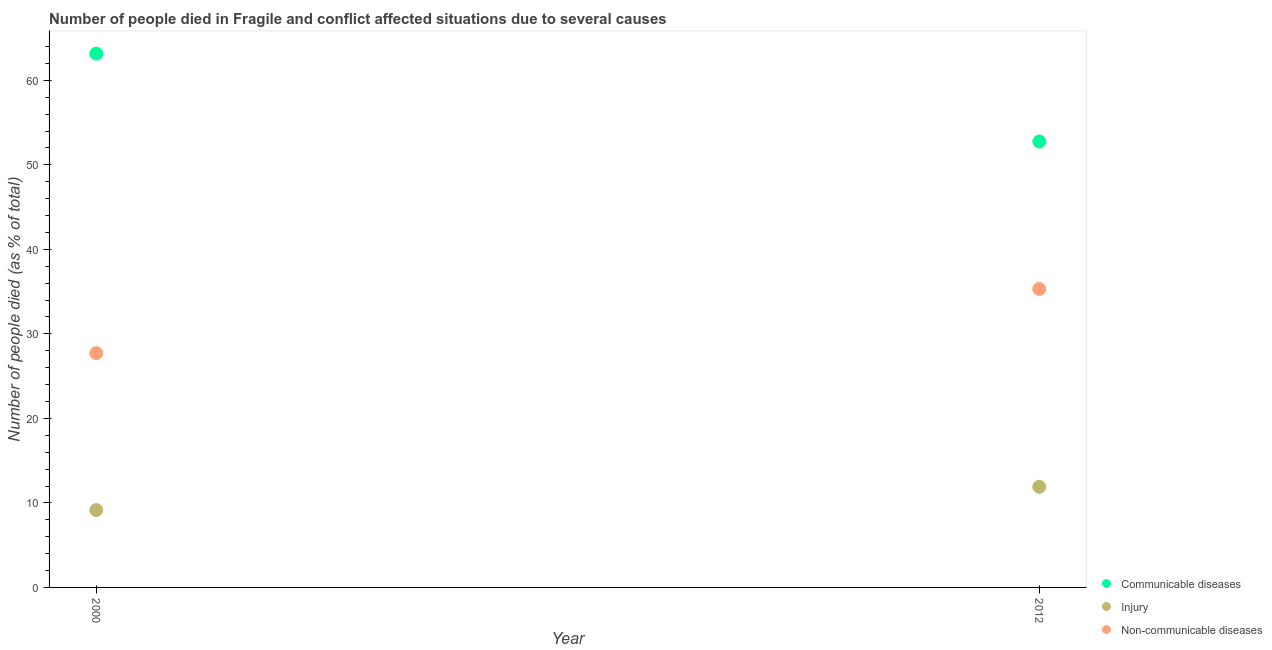How many different coloured dotlines are there?
Ensure brevity in your answer.  3. What is the number of people who dies of non-communicable diseases in 2012?
Make the answer very short. 35.31. Across all years, what is the maximum number of people who dies of non-communicable diseases?
Provide a succinct answer. 35.31. Across all years, what is the minimum number of people who died of injury?
Give a very brief answer. 9.15. In which year was the number of people who dies of non-communicable diseases maximum?
Keep it short and to the point. 2012. In which year was the number of people who dies of non-communicable diseases minimum?
Provide a succinct answer. 2000. What is the total number of people who died of communicable diseases in the graph?
Offer a very short reply. 115.91. What is the difference between the number of people who dies of non-communicable diseases in 2000 and that in 2012?
Provide a short and direct response. -7.59. What is the difference between the number of people who died of communicable diseases in 2012 and the number of people who dies of non-communicable diseases in 2000?
Keep it short and to the point. 25.04. What is the average number of people who dies of non-communicable diseases per year?
Give a very brief answer. 31.52. In the year 2012, what is the difference between the number of people who dies of non-communicable diseases and number of people who died of injury?
Provide a short and direct response. 23.41. What is the ratio of the number of people who dies of non-communicable diseases in 2000 to that in 2012?
Ensure brevity in your answer.  0.78. Is it the case that in every year, the sum of the number of people who died of communicable diseases and number of people who died of injury is greater than the number of people who dies of non-communicable diseases?
Offer a very short reply. Yes. How many dotlines are there?
Offer a terse response. 3. How many years are there in the graph?
Give a very brief answer. 2. Are the values on the major ticks of Y-axis written in scientific E-notation?
Provide a short and direct response. No. Does the graph contain any zero values?
Provide a succinct answer. No. How many legend labels are there?
Ensure brevity in your answer.  3. What is the title of the graph?
Provide a succinct answer. Number of people died in Fragile and conflict affected situations due to several causes. What is the label or title of the X-axis?
Your answer should be very brief. Year. What is the label or title of the Y-axis?
Your response must be concise. Number of people died (as % of total). What is the Number of people died (as % of total) of Communicable diseases in 2000?
Provide a succinct answer. 63.15. What is the Number of people died (as % of total) in Injury in 2000?
Give a very brief answer. 9.15. What is the Number of people died (as % of total) of Non-communicable diseases in 2000?
Your response must be concise. 27.72. What is the Number of people died (as % of total) in Communicable diseases in 2012?
Provide a succinct answer. 52.76. What is the Number of people died (as % of total) of Injury in 2012?
Provide a short and direct response. 11.91. What is the Number of people died (as % of total) of Non-communicable diseases in 2012?
Keep it short and to the point. 35.31. Across all years, what is the maximum Number of people died (as % of total) in Communicable diseases?
Offer a very short reply. 63.15. Across all years, what is the maximum Number of people died (as % of total) in Injury?
Give a very brief answer. 11.91. Across all years, what is the maximum Number of people died (as % of total) in Non-communicable diseases?
Offer a terse response. 35.31. Across all years, what is the minimum Number of people died (as % of total) in Communicable diseases?
Ensure brevity in your answer.  52.76. Across all years, what is the minimum Number of people died (as % of total) of Injury?
Ensure brevity in your answer.  9.15. Across all years, what is the minimum Number of people died (as % of total) of Non-communicable diseases?
Provide a succinct answer. 27.72. What is the total Number of people died (as % of total) of Communicable diseases in the graph?
Keep it short and to the point. 115.91. What is the total Number of people died (as % of total) in Injury in the graph?
Offer a terse response. 21.06. What is the total Number of people died (as % of total) of Non-communicable diseases in the graph?
Your answer should be compact. 63.03. What is the difference between the Number of people died (as % of total) in Communicable diseases in 2000 and that in 2012?
Offer a terse response. 10.39. What is the difference between the Number of people died (as % of total) in Injury in 2000 and that in 2012?
Your answer should be very brief. -2.75. What is the difference between the Number of people died (as % of total) of Non-communicable diseases in 2000 and that in 2012?
Provide a short and direct response. -7.59. What is the difference between the Number of people died (as % of total) of Communicable diseases in 2000 and the Number of people died (as % of total) of Injury in 2012?
Ensure brevity in your answer.  51.25. What is the difference between the Number of people died (as % of total) in Communicable diseases in 2000 and the Number of people died (as % of total) in Non-communicable diseases in 2012?
Your answer should be compact. 27.84. What is the difference between the Number of people died (as % of total) in Injury in 2000 and the Number of people died (as % of total) in Non-communicable diseases in 2012?
Your response must be concise. -26.16. What is the average Number of people died (as % of total) of Communicable diseases per year?
Your answer should be compact. 57.96. What is the average Number of people died (as % of total) in Injury per year?
Provide a short and direct response. 10.53. What is the average Number of people died (as % of total) in Non-communicable diseases per year?
Offer a very short reply. 31.52. In the year 2000, what is the difference between the Number of people died (as % of total) in Communicable diseases and Number of people died (as % of total) in Injury?
Provide a short and direct response. 54. In the year 2000, what is the difference between the Number of people died (as % of total) of Communicable diseases and Number of people died (as % of total) of Non-communicable diseases?
Offer a very short reply. 35.43. In the year 2000, what is the difference between the Number of people died (as % of total) of Injury and Number of people died (as % of total) of Non-communicable diseases?
Provide a succinct answer. -18.57. In the year 2012, what is the difference between the Number of people died (as % of total) in Communicable diseases and Number of people died (as % of total) in Injury?
Provide a short and direct response. 40.85. In the year 2012, what is the difference between the Number of people died (as % of total) of Communicable diseases and Number of people died (as % of total) of Non-communicable diseases?
Provide a short and direct response. 17.45. In the year 2012, what is the difference between the Number of people died (as % of total) in Injury and Number of people died (as % of total) in Non-communicable diseases?
Your answer should be compact. -23.41. What is the ratio of the Number of people died (as % of total) of Communicable diseases in 2000 to that in 2012?
Give a very brief answer. 1.2. What is the ratio of the Number of people died (as % of total) in Injury in 2000 to that in 2012?
Give a very brief answer. 0.77. What is the ratio of the Number of people died (as % of total) of Non-communicable diseases in 2000 to that in 2012?
Make the answer very short. 0.79. What is the difference between the highest and the second highest Number of people died (as % of total) of Communicable diseases?
Your answer should be compact. 10.39. What is the difference between the highest and the second highest Number of people died (as % of total) of Injury?
Your response must be concise. 2.75. What is the difference between the highest and the second highest Number of people died (as % of total) of Non-communicable diseases?
Make the answer very short. 7.59. What is the difference between the highest and the lowest Number of people died (as % of total) in Communicable diseases?
Provide a short and direct response. 10.39. What is the difference between the highest and the lowest Number of people died (as % of total) in Injury?
Make the answer very short. 2.75. What is the difference between the highest and the lowest Number of people died (as % of total) of Non-communicable diseases?
Make the answer very short. 7.59. 